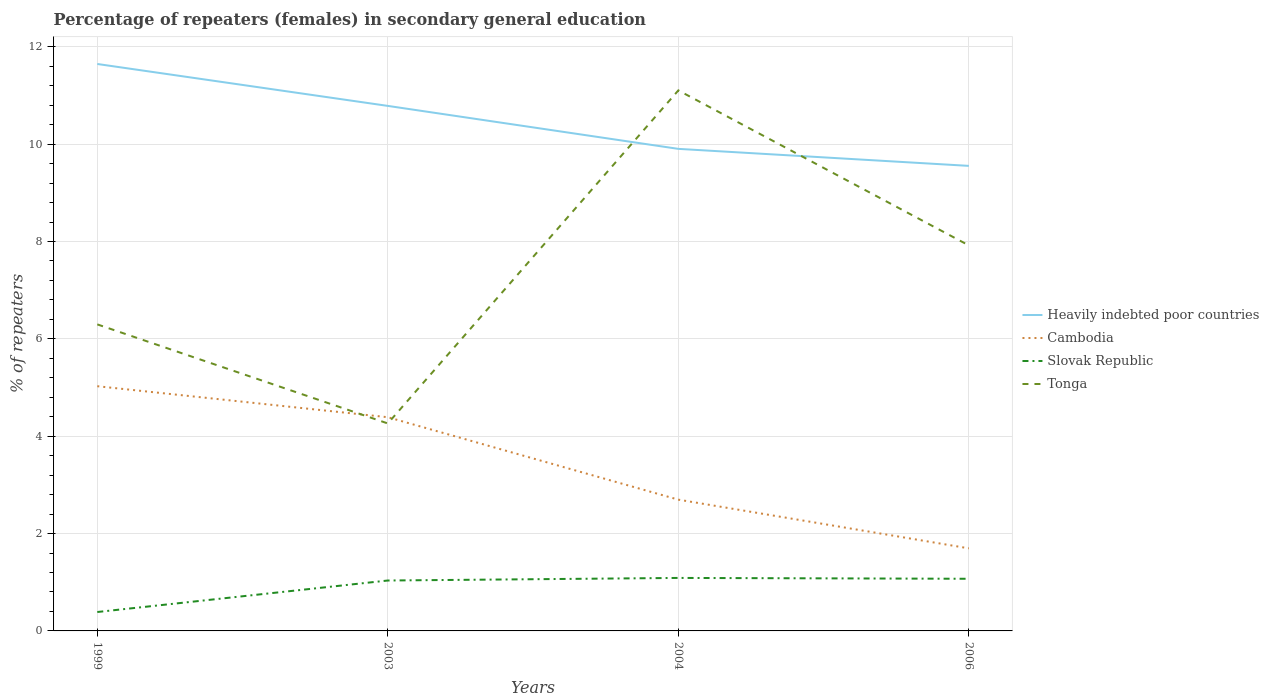How many different coloured lines are there?
Provide a succinct answer. 4. Does the line corresponding to Tonga intersect with the line corresponding to Slovak Republic?
Offer a terse response. No. Is the number of lines equal to the number of legend labels?
Keep it short and to the point. Yes. Across all years, what is the maximum percentage of female repeaters in Tonga?
Make the answer very short. 4.26. In which year was the percentage of female repeaters in Heavily indebted poor countries maximum?
Your answer should be compact. 2006. What is the total percentage of female repeaters in Cambodia in the graph?
Give a very brief answer. 2.69. What is the difference between the highest and the second highest percentage of female repeaters in Slovak Republic?
Ensure brevity in your answer.  0.7. How many lines are there?
Keep it short and to the point. 4. How many years are there in the graph?
Keep it short and to the point. 4. What is the difference between two consecutive major ticks on the Y-axis?
Your answer should be very brief. 2. Are the values on the major ticks of Y-axis written in scientific E-notation?
Your response must be concise. No. Does the graph contain grids?
Offer a very short reply. Yes. Where does the legend appear in the graph?
Your response must be concise. Center right. How many legend labels are there?
Your response must be concise. 4. What is the title of the graph?
Provide a succinct answer. Percentage of repeaters (females) in secondary general education. Does "Israel" appear as one of the legend labels in the graph?
Give a very brief answer. No. What is the label or title of the X-axis?
Ensure brevity in your answer.  Years. What is the label or title of the Y-axis?
Ensure brevity in your answer.  % of repeaters. What is the % of repeaters in Heavily indebted poor countries in 1999?
Provide a short and direct response. 11.65. What is the % of repeaters in Cambodia in 1999?
Your answer should be compact. 5.03. What is the % of repeaters in Slovak Republic in 1999?
Your answer should be very brief. 0.39. What is the % of repeaters of Tonga in 1999?
Offer a terse response. 6.3. What is the % of repeaters in Heavily indebted poor countries in 2003?
Keep it short and to the point. 10.79. What is the % of repeaters in Cambodia in 2003?
Keep it short and to the point. 4.39. What is the % of repeaters of Slovak Republic in 2003?
Your answer should be compact. 1.04. What is the % of repeaters in Tonga in 2003?
Offer a very short reply. 4.26. What is the % of repeaters of Heavily indebted poor countries in 2004?
Provide a succinct answer. 9.9. What is the % of repeaters of Cambodia in 2004?
Your response must be concise. 2.7. What is the % of repeaters of Slovak Republic in 2004?
Provide a succinct answer. 1.09. What is the % of repeaters of Tonga in 2004?
Make the answer very short. 11.1. What is the % of repeaters of Heavily indebted poor countries in 2006?
Your response must be concise. 9.55. What is the % of repeaters in Cambodia in 2006?
Give a very brief answer. 1.7. What is the % of repeaters of Slovak Republic in 2006?
Keep it short and to the point. 1.07. What is the % of repeaters of Tonga in 2006?
Offer a terse response. 7.92. Across all years, what is the maximum % of repeaters of Heavily indebted poor countries?
Keep it short and to the point. 11.65. Across all years, what is the maximum % of repeaters of Cambodia?
Give a very brief answer. 5.03. Across all years, what is the maximum % of repeaters of Slovak Republic?
Offer a very short reply. 1.09. Across all years, what is the maximum % of repeaters of Tonga?
Offer a terse response. 11.1. Across all years, what is the minimum % of repeaters in Heavily indebted poor countries?
Provide a short and direct response. 9.55. Across all years, what is the minimum % of repeaters in Cambodia?
Keep it short and to the point. 1.7. Across all years, what is the minimum % of repeaters of Slovak Republic?
Keep it short and to the point. 0.39. Across all years, what is the minimum % of repeaters of Tonga?
Provide a short and direct response. 4.26. What is the total % of repeaters in Heavily indebted poor countries in the graph?
Provide a succinct answer. 41.89. What is the total % of repeaters of Cambodia in the graph?
Make the answer very short. 13.81. What is the total % of repeaters in Slovak Republic in the graph?
Keep it short and to the point. 3.58. What is the total % of repeaters in Tonga in the graph?
Give a very brief answer. 29.58. What is the difference between the % of repeaters in Heavily indebted poor countries in 1999 and that in 2003?
Provide a succinct answer. 0.86. What is the difference between the % of repeaters in Cambodia in 1999 and that in 2003?
Give a very brief answer. 0.64. What is the difference between the % of repeaters of Slovak Republic in 1999 and that in 2003?
Ensure brevity in your answer.  -0.65. What is the difference between the % of repeaters of Tonga in 1999 and that in 2003?
Offer a very short reply. 2.04. What is the difference between the % of repeaters in Heavily indebted poor countries in 1999 and that in 2004?
Make the answer very short. 1.74. What is the difference between the % of repeaters of Cambodia in 1999 and that in 2004?
Ensure brevity in your answer.  2.33. What is the difference between the % of repeaters in Slovak Republic in 1999 and that in 2004?
Provide a succinct answer. -0.7. What is the difference between the % of repeaters of Tonga in 1999 and that in 2004?
Make the answer very short. -4.81. What is the difference between the % of repeaters of Heavily indebted poor countries in 1999 and that in 2006?
Make the answer very short. 2.09. What is the difference between the % of repeaters of Cambodia in 1999 and that in 2006?
Keep it short and to the point. 3.33. What is the difference between the % of repeaters in Slovak Republic in 1999 and that in 2006?
Provide a short and direct response. -0.68. What is the difference between the % of repeaters of Tonga in 1999 and that in 2006?
Your response must be concise. -1.62. What is the difference between the % of repeaters in Heavily indebted poor countries in 2003 and that in 2004?
Provide a short and direct response. 0.88. What is the difference between the % of repeaters in Cambodia in 2003 and that in 2004?
Provide a short and direct response. 1.69. What is the difference between the % of repeaters in Slovak Republic in 2003 and that in 2004?
Your response must be concise. -0.05. What is the difference between the % of repeaters of Tonga in 2003 and that in 2004?
Give a very brief answer. -6.84. What is the difference between the % of repeaters of Heavily indebted poor countries in 2003 and that in 2006?
Your answer should be very brief. 1.23. What is the difference between the % of repeaters in Cambodia in 2003 and that in 2006?
Offer a terse response. 2.69. What is the difference between the % of repeaters of Slovak Republic in 2003 and that in 2006?
Give a very brief answer. -0.04. What is the difference between the % of repeaters in Tonga in 2003 and that in 2006?
Offer a very short reply. -3.66. What is the difference between the % of repeaters in Heavily indebted poor countries in 2004 and that in 2006?
Your answer should be very brief. 0.35. What is the difference between the % of repeaters of Cambodia in 2004 and that in 2006?
Give a very brief answer. 1. What is the difference between the % of repeaters of Slovak Republic in 2004 and that in 2006?
Keep it short and to the point. 0.02. What is the difference between the % of repeaters in Tonga in 2004 and that in 2006?
Your answer should be compact. 3.19. What is the difference between the % of repeaters of Heavily indebted poor countries in 1999 and the % of repeaters of Cambodia in 2003?
Ensure brevity in your answer.  7.26. What is the difference between the % of repeaters in Heavily indebted poor countries in 1999 and the % of repeaters in Slovak Republic in 2003?
Provide a succinct answer. 10.61. What is the difference between the % of repeaters of Heavily indebted poor countries in 1999 and the % of repeaters of Tonga in 2003?
Give a very brief answer. 7.38. What is the difference between the % of repeaters in Cambodia in 1999 and the % of repeaters in Slovak Republic in 2003?
Ensure brevity in your answer.  3.99. What is the difference between the % of repeaters in Cambodia in 1999 and the % of repeaters in Tonga in 2003?
Provide a short and direct response. 0.77. What is the difference between the % of repeaters in Slovak Republic in 1999 and the % of repeaters in Tonga in 2003?
Provide a short and direct response. -3.87. What is the difference between the % of repeaters in Heavily indebted poor countries in 1999 and the % of repeaters in Cambodia in 2004?
Provide a succinct answer. 8.95. What is the difference between the % of repeaters in Heavily indebted poor countries in 1999 and the % of repeaters in Slovak Republic in 2004?
Provide a succinct answer. 10.56. What is the difference between the % of repeaters of Heavily indebted poor countries in 1999 and the % of repeaters of Tonga in 2004?
Offer a terse response. 0.54. What is the difference between the % of repeaters of Cambodia in 1999 and the % of repeaters of Slovak Republic in 2004?
Make the answer very short. 3.94. What is the difference between the % of repeaters in Cambodia in 1999 and the % of repeaters in Tonga in 2004?
Offer a terse response. -6.08. What is the difference between the % of repeaters in Slovak Republic in 1999 and the % of repeaters in Tonga in 2004?
Ensure brevity in your answer.  -10.72. What is the difference between the % of repeaters of Heavily indebted poor countries in 1999 and the % of repeaters of Cambodia in 2006?
Offer a very short reply. 9.95. What is the difference between the % of repeaters of Heavily indebted poor countries in 1999 and the % of repeaters of Slovak Republic in 2006?
Provide a succinct answer. 10.58. What is the difference between the % of repeaters of Heavily indebted poor countries in 1999 and the % of repeaters of Tonga in 2006?
Your answer should be compact. 3.73. What is the difference between the % of repeaters of Cambodia in 1999 and the % of repeaters of Slovak Republic in 2006?
Give a very brief answer. 3.96. What is the difference between the % of repeaters of Cambodia in 1999 and the % of repeaters of Tonga in 2006?
Keep it short and to the point. -2.89. What is the difference between the % of repeaters in Slovak Republic in 1999 and the % of repeaters in Tonga in 2006?
Make the answer very short. -7.53. What is the difference between the % of repeaters in Heavily indebted poor countries in 2003 and the % of repeaters in Cambodia in 2004?
Ensure brevity in your answer.  8.09. What is the difference between the % of repeaters in Heavily indebted poor countries in 2003 and the % of repeaters in Slovak Republic in 2004?
Provide a short and direct response. 9.7. What is the difference between the % of repeaters of Heavily indebted poor countries in 2003 and the % of repeaters of Tonga in 2004?
Ensure brevity in your answer.  -0.32. What is the difference between the % of repeaters of Cambodia in 2003 and the % of repeaters of Slovak Republic in 2004?
Provide a short and direct response. 3.3. What is the difference between the % of repeaters in Cambodia in 2003 and the % of repeaters in Tonga in 2004?
Your answer should be compact. -6.71. What is the difference between the % of repeaters in Slovak Republic in 2003 and the % of repeaters in Tonga in 2004?
Provide a short and direct response. -10.07. What is the difference between the % of repeaters in Heavily indebted poor countries in 2003 and the % of repeaters in Cambodia in 2006?
Ensure brevity in your answer.  9.09. What is the difference between the % of repeaters in Heavily indebted poor countries in 2003 and the % of repeaters in Slovak Republic in 2006?
Give a very brief answer. 9.71. What is the difference between the % of repeaters in Heavily indebted poor countries in 2003 and the % of repeaters in Tonga in 2006?
Keep it short and to the point. 2.87. What is the difference between the % of repeaters of Cambodia in 2003 and the % of repeaters of Slovak Republic in 2006?
Keep it short and to the point. 3.32. What is the difference between the % of repeaters of Cambodia in 2003 and the % of repeaters of Tonga in 2006?
Give a very brief answer. -3.53. What is the difference between the % of repeaters in Slovak Republic in 2003 and the % of repeaters in Tonga in 2006?
Provide a short and direct response. -6.88. What is the difference between the % of repeaters of Heavily indebted poor countries in 2004 and the % of repeaters of Cambodia in 2006?
Offer a very short reply. 8.21. What is the difference between the % of repeaters of Heavily indebted poor countries in 2004 and the % of repeaters of Slovak Republic in 2006?
Your answer should be compact. 8.83. What is the difference between the % of repeaters of Heavily indebted poor countries in 2004 and the % of repeaters of Tonga in 2006?
Your answer should be compact. 1.98. What is the difference between the % of repeaters of Cambodia in 2004 and the % of repeaters of Slovak Republic in 2006?
Make the answer very short. 1.63. What is the difference between the % of repeaters in Cambodia in 2004 and the % of repeaters in Tonga in 2006?
Your answer should be compact. -5.22. What is the difference between the % of repeaters in Slovak Republic in 2004 and the % of repeaters in Tonga in 2006?
Your answer should be very brief. -6.83. What is the average % of repeaters of Heavily indebted poor countries per year?
Provide a succinct answer. 10.47. What is the average % of repeaters in Cambodia per year?
Keep it short and to the point. 3.45. What is the average % of repeaters in Slovak Republic per year?
Provide a succinct answer. 0.9. What is the average % of repeaters in Tonga per year?
Offer a terse response. 7.4. In the year 1999, what is the difference between the % of repeaters of Heavily indebted poor countries and % of repeaters of Cambodia?
Make the answer very short. 6.62. In the year 1999, what is the difference between the % of repeaters of Heavily indebted poor countries and % of repeaters of Slovak Republic?
Your response must be concise. 11.26. In the year 1999, what is the difference between the % of repeaters of Heavily indebted poor countries and % of repeaters of Tonga?
Make the answer very short. 5.35. In the year 1999, what is the difference between the % of repeaters of Cambodia and % of repeaters of Slovak Republic?
Provide a succinct answer. 4.64. In the year 1999, what is the difference between the % of repeaters in Cambodia and % of repeaters in Tonga?
Give a very brief answer. -1.27. In the year 1999, what is the difference between the % of repeaters in Slovak Republic and % of repeaters in Tonga?
Offer a terse response. -5.91. In the year 2003, what is the difference between the % of repeaters of Heavily indebted poor countries and % of repeaters of Cambodia?
Your answer should be compact. 6.4. In the year 2003, what is the difference between the % of repeaters of Heavily indebted poor countries and % of repeaters of Slovak Republic?
Your answer should be compact. 9.75. In the year 2003, what is the difference between the % of repeaters of Heavily indebted poor countries and % of repeaters of Tonga?
Give a very brief answer. 6.52. In the year 2003, what is the difference between the % of repeaters in Cambodia and % of repeaters in Slovak Republic?
Offer a terse response. 3.35. In the year 2003, what is the difference between the % of repeaters in Cambodia and % of repeaters in Tonga?
Your answer should be very brief. 0.13. In the year 2003, what is the difference between the % of repeaters in Slovak Republic and % of repeaters in Tonga?
Offer a terse response. -3.23. In the year 2004, what is the difference between the % of repeaters of Heavily indebted poor countries and % of repeaters of Cambodia?
Offer a very short reply. 7.21. In the year 2004, what is the difference between the % of repeaters in Heavily indebted poor countries and % of repeaters in Slovak Republic?
Offer a very short reply. 8.81. In the year 2004, what is the difference between the % of repeaters of Heavily indebted poor countries and % of repeaters of Tonga?
Your response must be concise. -1.2. In the year 2004, what is the difference between the % of repeaters of Cambodia and % of repeaters of Slovak Republic?
Keep it short and to the point. 1.61. In the year 2004, what is the difference between the % of repeaters in Cambodia and % of repeaters in Tonga?
Give a very brief answer. -8.41. In the year 2004, what is the difference between the % of repeaters in Slovak Republic and % of repeaters in Tonga?
Keep it short and to the point. -10.02. In the year 2006, what is the difference between the % of repeaters of Heavily indebted poor countries and % of repeaters of Cambodia?
Ensure brevity in your answer.  7.86. In the year 2006, what is the difference between the % of repeaters of Heavily indebted poor countries and % of repeaters of Slovak Republic?
Provide a succinct answer. 8.48. In the year 2006, what is the difference between the % of repeaters of Heavily indebted poor countries and % of repeaters of Tonga?
Ensure brevity in your answer.  1.63. In the year 2006, what is the difference between the % of repeaters of Cambodia and % of repeaters of Slovak Republic?
Make the answer very short. 0.62. In the year 2006, what is the difference between the % of repeaters in Cambodia and % of repeaters in Tonga?
Keep it short and to the point. -6.22. In the year 2006, what is the difference between the % of repeaters in Slovak Republic and % of repeaters in Tonga?
Provide a succinct answer. -6.85. What is the ratio of the % of repeaters in Heavily indebted poor countries in 1999 to that in 2003?
Make the answer very short. 1.08. What is the ratio of the % of repeaters in Cambodia in 1999 to that in 2003?
Make the answer very short. 1.15. What is the ratio of the % of repeaters of Slovak Republic in 1999 to that in 2003?
Give a very brief answer. 0.38. What is the ratio of the % of repeaters in Tonga in 1999 to that in 2003?
Your answer should be very brief. 1.48. What is the ratio of the % of repeaters in Heavily indebted poor countries in 1999 to that in 2004?
Make the answer very short. 1.18. What is the ratio of the % of repeaters of Cambodia in 1999 to that in 2004?
Ensure brevity in your answer.  1.86. What is the ratio of the % of repeaters in Slovak Republic in 1999 to that in 2004?
Keep it short and to the point. 0.36. What is the ratio of the % of repeaters in Tonga in 1999 to that in 2004?
Your response must be concise. 0.57. What is the ratio of the % of repeaters of Heavily indebted poor countries in 1999 to that in 2006?
Provide a succinct answer. 1.22. What is the ratio of the % of repeaters in Cambodia in 1999 to that in 2006?
Your answer should be very brief. 2.96. What is the ratio of the % of repeaters of Slovak Republic in 1999 to that in 2006?
Offer a terse response. 0.36. What is the ratio of the % of repeaters in Tonga in 1999 to that in 2006?
Ensure brevity in your answer.  0.8. What is the ratio of the % of repeaters of Heavily indebted poor countries in 2003 to that in 2004?
Provide a short and direct response. 1.09. What is the ratio of the % of repeaters of Cambodia in 2003 to that in 2004?
Offer a very short reply. 1.63. What is the ratio of the % of repeaters in Slovak Republic in 2003 to that in 2004?
Keep it short and to the point. 0.95. What is the ratio of the % of repeaters of Tonga in 2003 to that in 2004?
Your answer should be compact. 0.38. What is the ratio of the % of repeaters of Heavily indebted poor countries in 2003 to that in 2006?
Your response must be concise. 1.13. What is the ratio of the % of repeaters of Cambodia in 2003 to that in 2006?
Your answer should be compact. 2.59. What is the ratio of the % of repeaters in Slovak Republic in 2003 to that in 2006?
Provide a succinct answer. 0.97. What is the ratio of the % of repeaters in Tonga in 2003 to that in 2006?
Your answer should be compact. 0.54. What is the ratio of the % of repeaters in Heavily indebted poor countries in 2004 to that in 2006?
Provide a succinct answer. 1.04. What is the ratio of the % of repeaters of Cambodia in 2004 to that in 2006?
Offer a very short reply. 1.59. What is the ratio of the % of repeaters in Slovak Republic in 2004 to that in 2006?
Your answer should be very brief. 1.02. What is the ratio of the % of repeaters of Tonga in 2004 to that in 2006?
Keep it short and to the point. 1.4. What is the difference between the highest and the second highest % of repeaters in Heavily indebted poor countries?
Your response must be concise. 0.86. What is the difference between the highest and the second highest % of repeaters in Cambodia?
Make the answer very short. 0.64. What is the difference between the highest and the second highest % of repeaters in Slovak Republic?
Your answer should be very brief. 0.02. What is the difference between the highest and the second highest % of repeaters of Tonga?
Offer a very short reply. 3.19. What is the difference between the highest and the lowest % of repeaters of Heavily indebted poor countries?
Provide a short and direct response. 2.09. What is the difference between the highest and the lowest % of repeaters in Cambodia?
Give a very brief answer. 3.33. What is the difference between the highest and the lowest % of repeaters in Slovak Republic?
Offer a very short reply. 0.7. What is the difference between the highest and the lowest % of repeaters of Tonga?
Offer a very short reply. 6.84. 